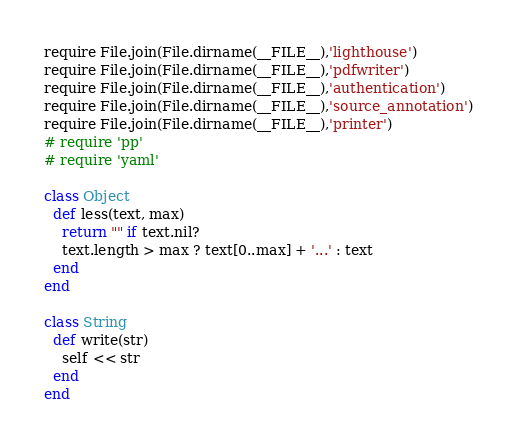Convert code to text. <code><loc_0><loc_0><loc_500><loc_500><_Ruby_>require File.join(File.dirname(__FILE__),'lighthouse')
require File.join(File.dirname(__FILE__),'pdfwriter')
require File.join(File.dirname(__FILE__),'authentication')
require File.join(File.dirname(__FILE__),'source_annotation')
require File.join(File.dirname(__FILE__),'printer')
# require 'pp'
# require 'yaml'

class Object
  def less(text, max)
    return "" if text.nil?
    text.length > max ? text[0..max] + '...' : text
  end
end

class String
  def write(str)
    self << str 
  end
end</code> 